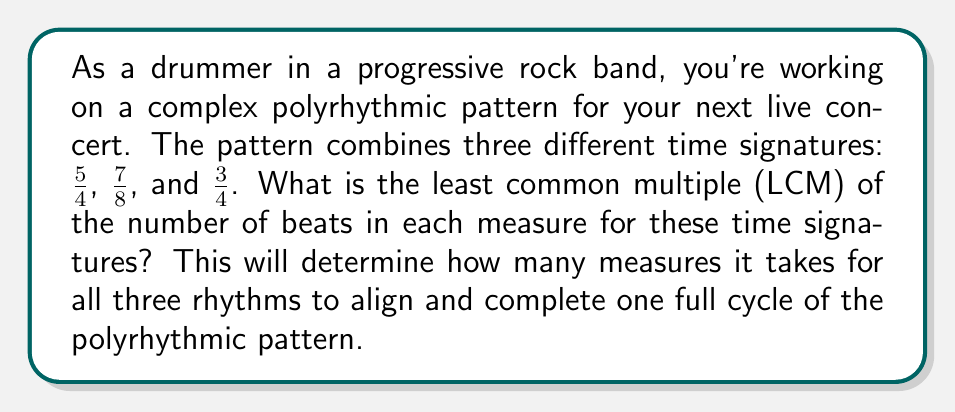Help me with this question. To solve this problem, we need to follow these steps:

1) First, let's convert all time signatures to the same denominator (8th notes):
   5/4 = 10/8
   7/8 remains 7/8
   3/4 = 6/8

2) Now we need to find the LCM of 10, 7, and 6.

3) To find the LCM, let's first find the prime factorization of each number:
   10 = 2 × 5
   7 = 7
   6 = 2 × 3

4) The LCM will include the highest power of each prime factor:
   LCM = $2^1 × 3^1 × 5^1 × 7^1$

5) Calculate the result:
   $2 × 3 × 5 × 7 = 210$

6) Therefore, the polyrhythmic pattern will repeat every 210 eighth notes.

7) To convert this back to measures:
   5/4 (10/8): 210 ÷ 10 = 21 measures
   7/8: 210 ÷ 7 = 30 measures
   3/4 (6/8): 210 ÷ 6 = 35 measures

Thus, the pattern will repeat every 21 measures of 5/4, 30 measures of 7/8, and 35 measures of 3/4.
Answer: The least common multiple of the number of beats in each measure for the time signatures 5/4, 7/8, and 3/4 is 210 eighth notes, or 21 measures of 5/4, 30 measures of 7/8, and 35 measures of 3/4. 